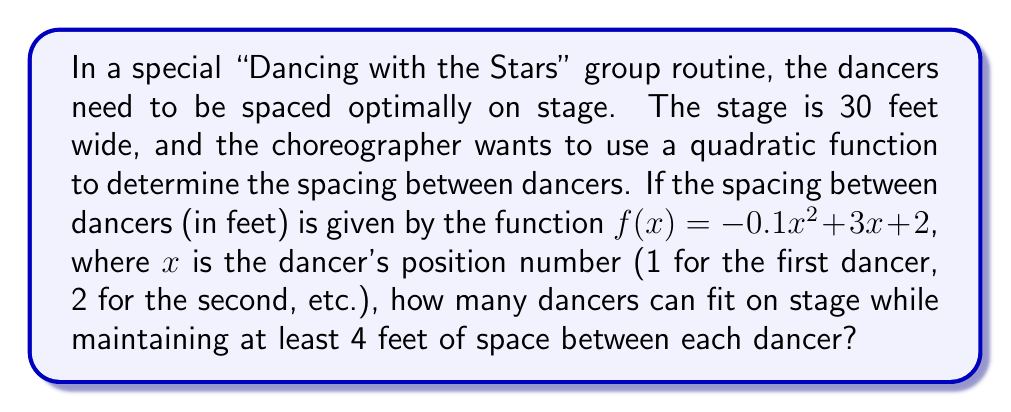Show me your answer to this math problem. To solve this problem, we need to follow these steps:

1) The spacing between dancers is given by $f(x) = -0.1x^2 + 3x + 2$

2) We need to find the maximum number of dancers while ensuring each pair of adjacent dancers has at least 4 feet between them.

3) Let's calculate the spacing for each pair of dancers:
   
   Between 1st and 2nd: $f(1) = -0.1(1)^2 + 3(1) + 2 = 4.9$ feet
   Between 2nd and 3rd: $f(2) = -0.1(2)^2 + 3(2) + 2 = 7.6$ feet
   Between 3rd and 4th: $f(3) = -0.1(3)^2 + 3(3) + 2 = 10.1$ feet
   Between 4th and 5th: $f(4) = -0.1(4)^2 + 3(4) + 2 = 12.4$ feet
   Between 5th and 6th: $f(5) = -0.1(5)^2 + 3(5) + 2 = 14.5$ feet
   Between 6th and 7th: $f(6) = -0.1(6)^2 + 3(6) + 2 = 16.4$ feet
   Between 7th and 8th: $f(7) = -0.1(7)^2 + 3(7) + 2 = 18.1$ feet

4) All these spacings are above 4 feet, so we can continue.

5) Now, let's sum up these spacings to see how much total space is used:
   
   $4.9 + 7.6 + 10.1 + 12.4 + 14.5 + 16.4 + 18.1 = 84$ feet

6) This exceeds the stage width of 30 feet, so we need to stop earlier.

7) Let's sum up to the 4th spacing:
   
   $4.9 + 7.6 + 10.1 + 12.4 = 35$ feet

8) This is still over 30 feet, so we need to stop at the 3rd spacing:
   
   $4.9 + 7.6 + 10.1 = 22.6$ feet

9) This is less than 30 feet and includes 3 spacings, which means 4 dancers can fit on stage.
Answer: 4 dancers 